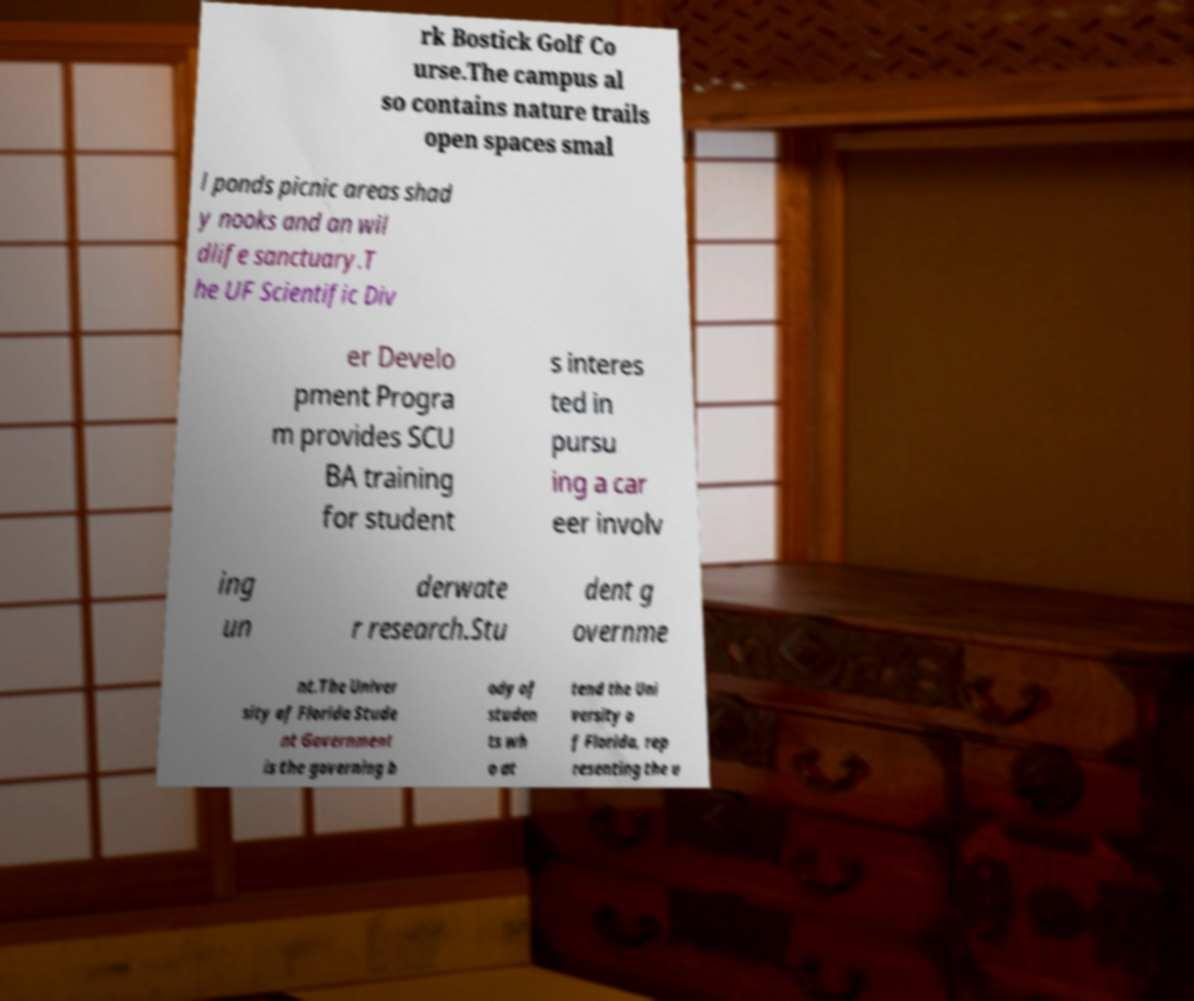Please identify and transcribe the text found in this image. rk Bostick Golf Co urse.The campus al so contains nature trails open spaces smal l ponds picnic areas shad y nooks and an wil dlife sanctuary.T he UF Scientific Div er Develo pment Progra m provides SCU BA training for student s interes ted in pursu ing a car eer involv ing un derwate r research.Stu dent g overnme nt.The Univer sity of Florida Stude nt Government is the governing b ody of studen ts wh o at tend the Uni versity o f Florida, rep resenting the u 